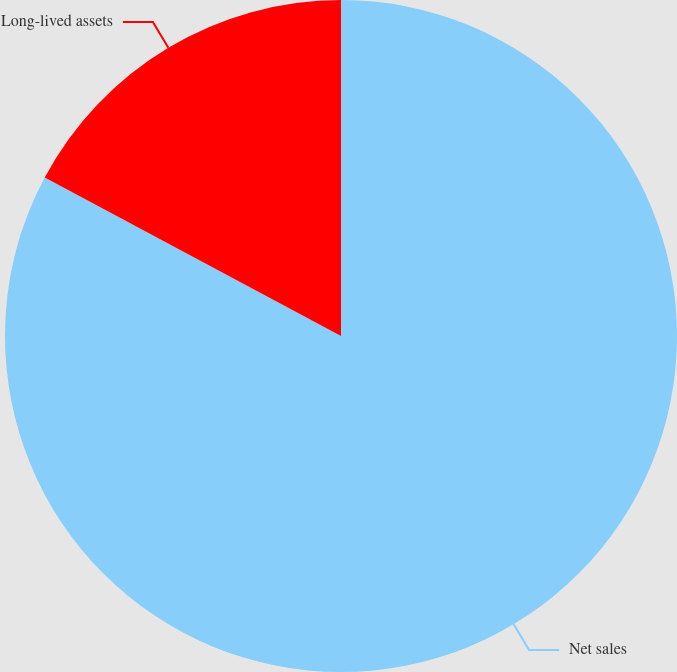Convert chart to OTSL. <chart><loc_0><loc_0><loc_500><loc_500><pie_chart><fcel>Net sales<fcel>Long-lived assets<nl><fcel>82.82%<fcel>17.18%<nl></chart> 